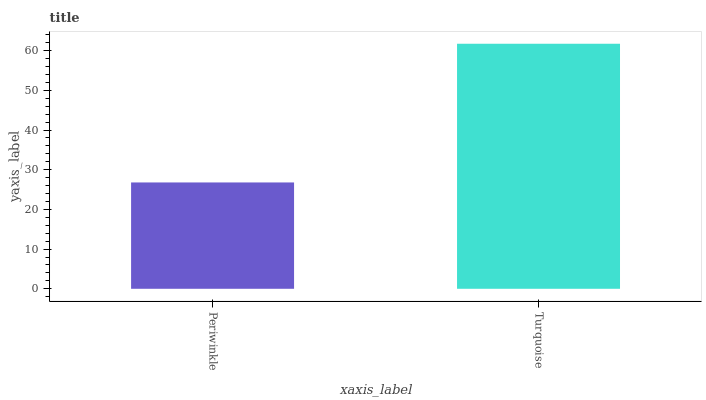Is Periwinkle the minimum?
Answer yes or no. Yes. Is Turquoise the maximum?
Answer yes or no. Yes. Is Turquoise the minimum?
Answer yes or no. No. Is Turquoise greater than Periwinkle?
Answer yes or no. Yes. Is Periwinkle less than Turquoise?
Answer yes or no. Yes. Is Periwinkle greater than Turquoise?
Answer yes or no. No. Is Turquoise less than Periwinkle?
Answer yes or no. No. Is Turquoise the high median?
Answer yes or no. Yes. Is Periwinkle the low median?
Answer yes or no. Yes. Is Periwinkle the high median?
Answer yes or no. No. Is Turquoise the low median?
Answer yes or no. No. 